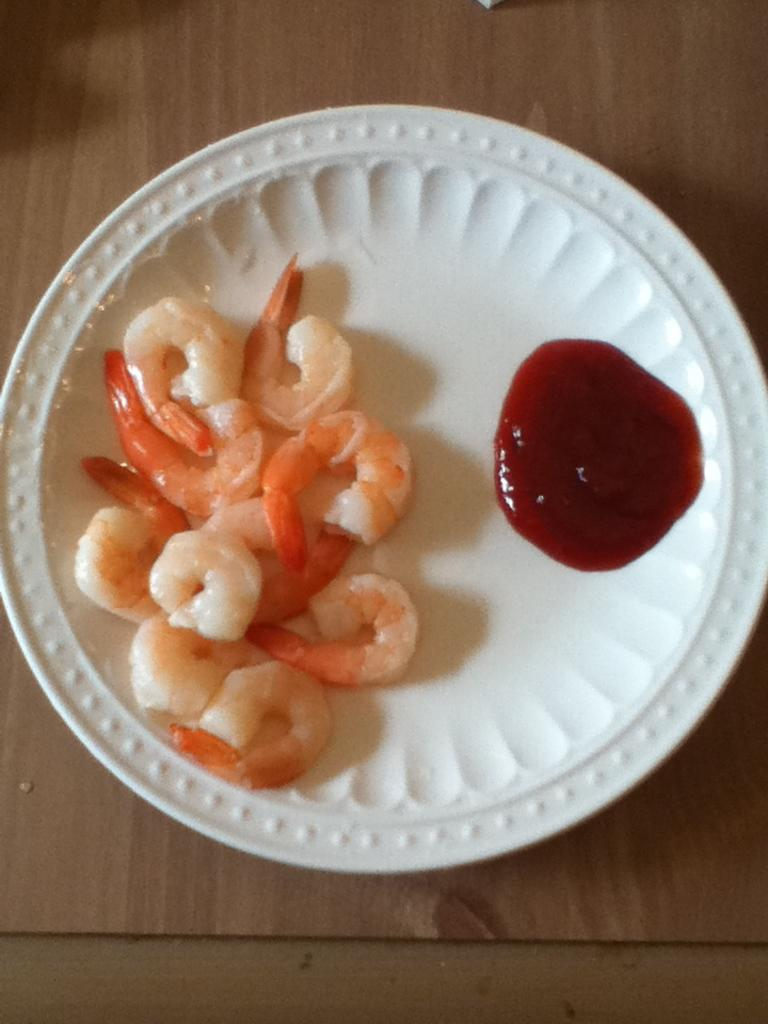What is the main subject of the image? There is a food item in the image. How is the food item presented in the image? The food item is placed on a plate. Can you tell me the price of the snail in the image? There is no snail present in the image, and therefore no price can be determined. 